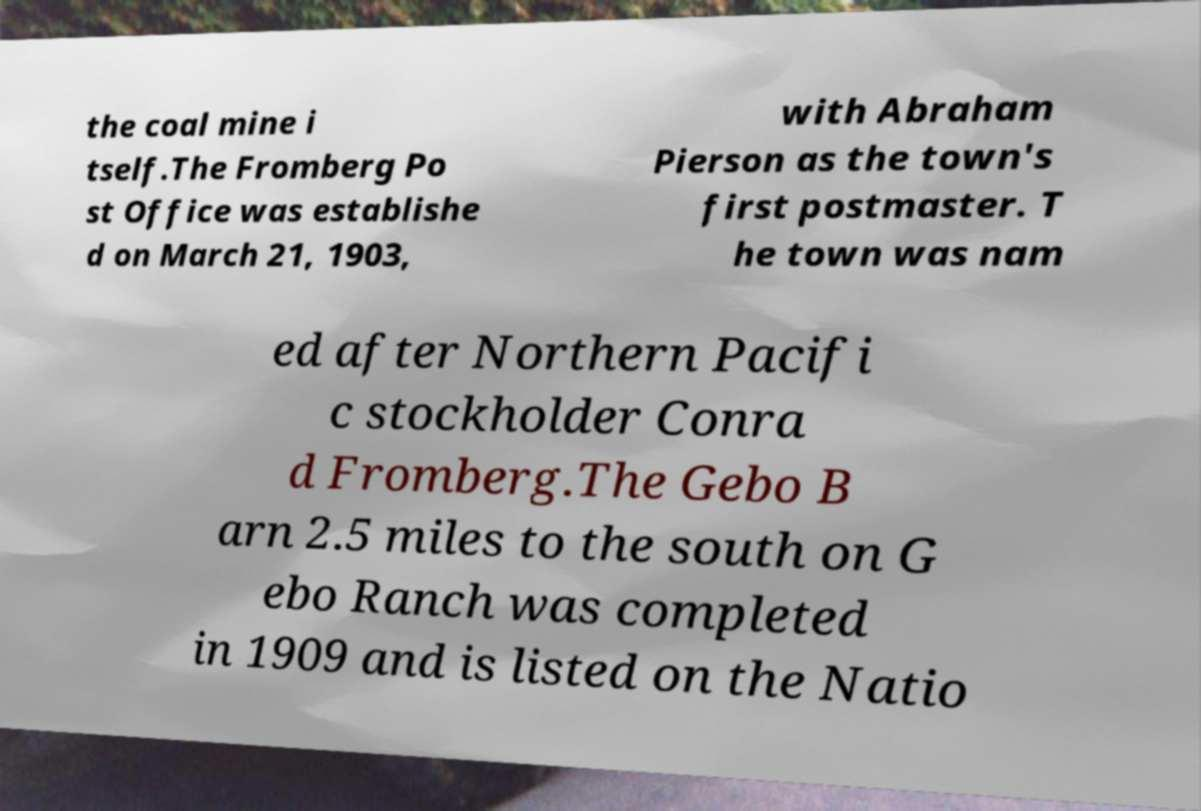Can you accurately transcribe the text from the provided image for me? the coal mine i tself.The Fromberg Po st Office was establishe d on March 21, 1903, with Abraham Pierson as the town's first postmaster. T he town was nam ed after Northern Pacifi c stockholder Conra d Fromberg.The Gebo B arn 2.5 miles to the south on G ebo Ranch was completed in 1909 and is listed on the Natio 